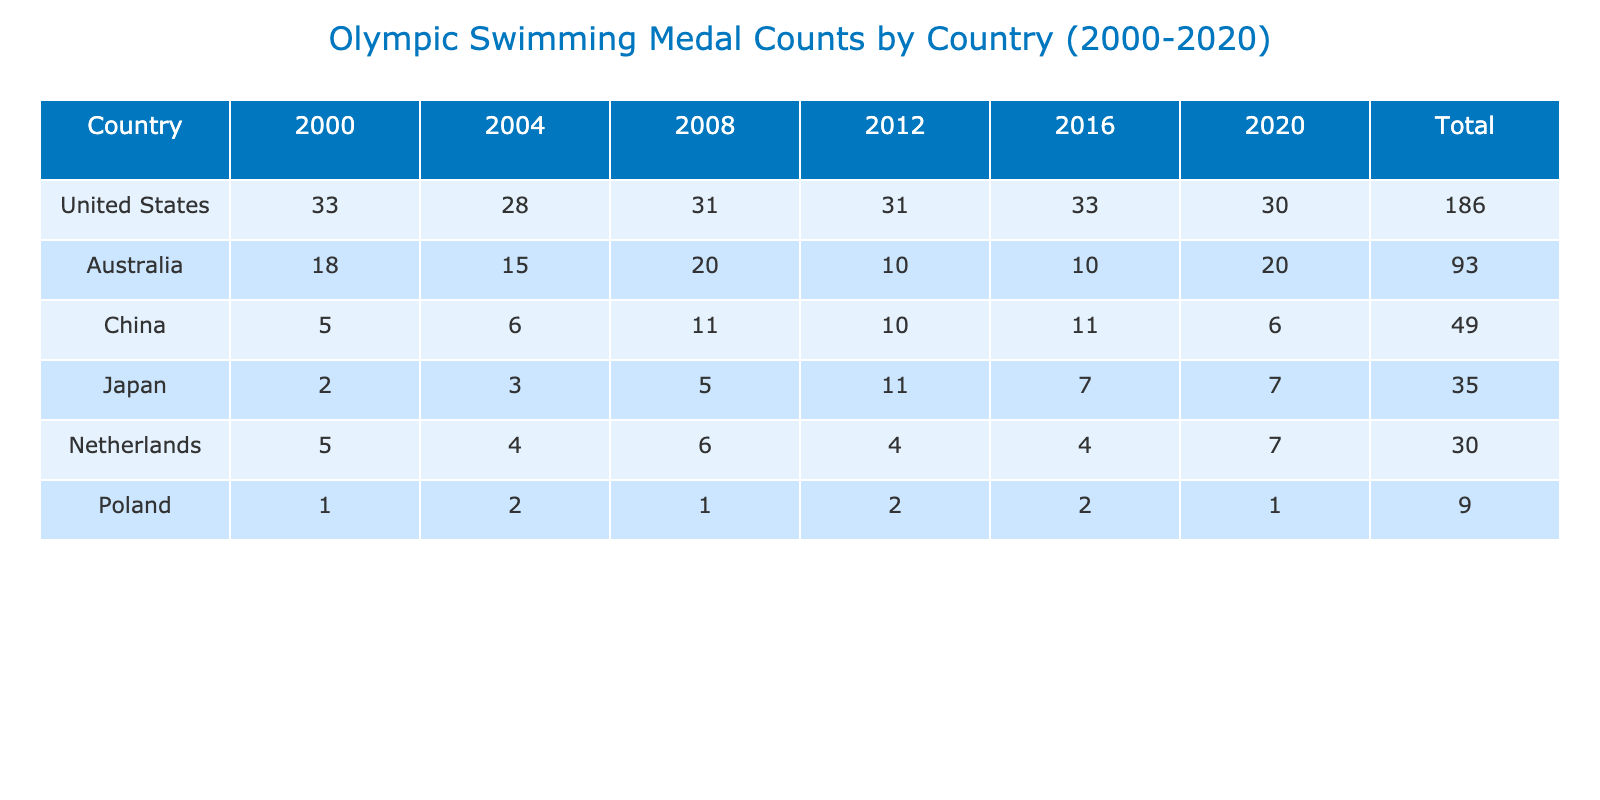What country won the most gold medals in swimming from 2000 to 2020? The table reveals that the United States won 14 gold medals in 2000, which is the highest count across all countries for that year. Although they had lower counts in subsequent years, their total gold medal count from 2000 to 2020 exceeds that of other countries. Thus, the United States is the country with the most gold medals overall.
Answer: United States Which year had the highest total medal count for Australia? By checking the table, we see that in 2008, Australia had a total of 20 medals which is the highest value for the country across all years shown.
Answer: 2008 True or False: Japan won more bronze medals than gold medals in 2016. In the table, Japan is shown to have won 3 bronze medals and 2 gold medals in 2016. Since 3 is greater than 2, Japan indeed won more bronze medals than gold medals that year.
Answer: True What is the difference in total medals won by the United States in 2012 compared to 2016? The United States achieved a total of 31 medals in both 2012 and 2016, respectively. The difference in total medals is 31 - 33 = -2, indicating they won 2 more medals in 2016. Therefore the answer is zero as the numbers are equal.
Answer: 0 Which country had the lowest medal count in 2000? When examining the table, Poland is listed as having only 1 total medal in 2000 compared to other countries. No other country had a lower count than this, thus confirming Poland had the lowest count in that year.
Answer: Poland What is the average total medal count for China across all the years? The total medals for China from 2000 to 2020 can be summed up: 5 + 6 + 11 + 10 + 11 + 6 = 49. There are 6 years in total, so dividing the total by the number of years gives an average: 49 / 6 ≈ 8.17.
Answer: 8.17 How many countries won a total of 10 medals or more in 2012? In the table for 2012, the countries and their total medal counts are as follows: United States (31), Australia (10), China (10), and Japan (11). Thus, we see that 4 countries achieved this milestone in 2012.
Answer: 4 